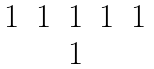Convert formula to latex. <formula><loc_0><loc_0><loc_500><loc_500>\begin{matrix} 1 & 1 & 1 & 1 & 1 \\ & & 1 & & \end{matrix}</formula> 